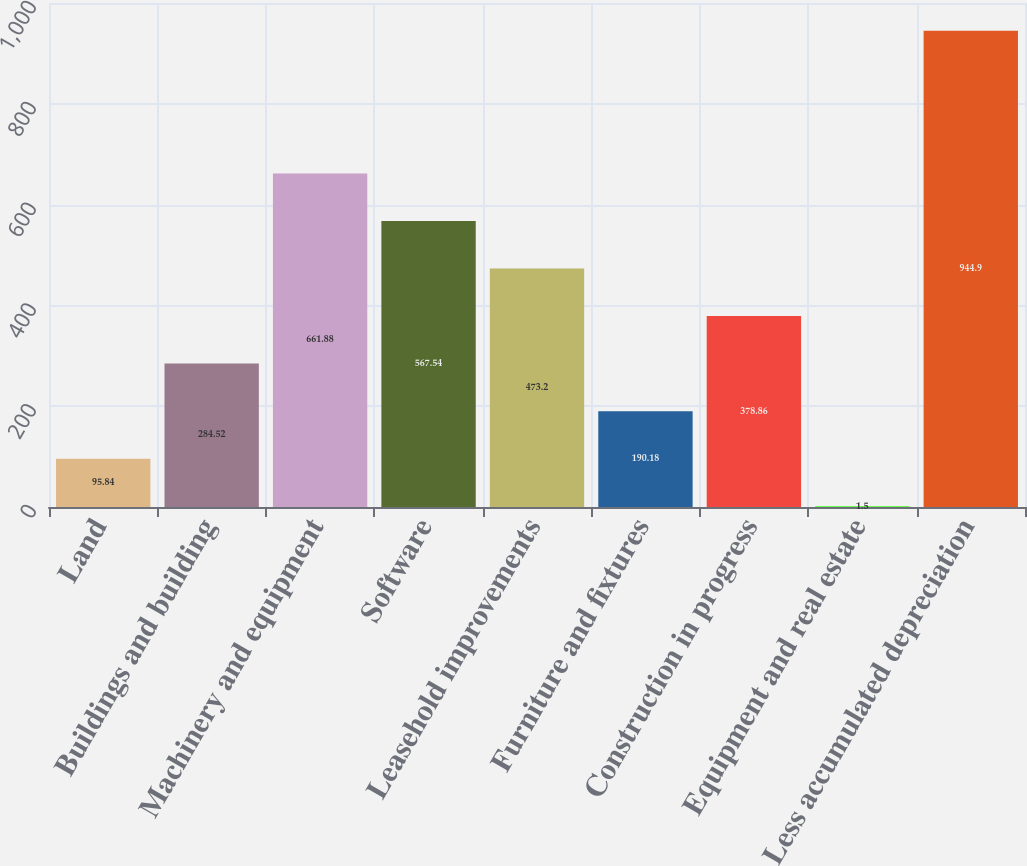Convert chart. <chart><loc_0><loc_0><loc_500><loc_500><bar_chart><fcel>Land<fcel>Buildings and building<fcel>Machinery and equipment<fcel>Software<fcel>Leasehold improvements<fcel>Furniture and fixtures<fcel>Construction in progress<fcel>Equipment and real estate<fcel>Less accumulated depreciation<nl><fcel>95.84<fcel>284.52<fcel>661.88<fcel>567.54<fcel>473.2<fcel>190.18<fcel>378.86<fcel>1.5<fcel>944.9<nl></chart> 